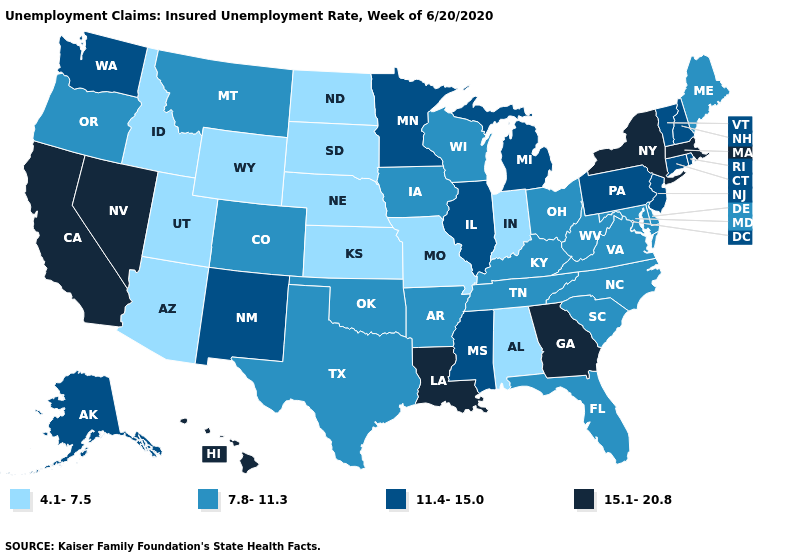What is the value of Louisiana?
Concise answer only. 15.1-20.8. What is the value of Colorado?
Quick response, please. 7.8-11.3. What is the highest value in the Northeast ?
Quick response, please. 15.1-20.8. What is the lowest value in states that border New York?
Short answer required. 11.4-15.0. Does Oklahoma have the same value as Texas?
Give a very brief answer. Yes. What is the value of Iowa?
Short answer required. 7.8-11.3. Does the first symbol in the legend represent the smallest category?
Give a very brief answer. Yes. What is the highest value in the USA?
Write a very short answer. 15.1-20.8. What is the value of South Dakota?
Be succinct. 4.1-7.5. What is the value of Delaware?
Keep it brief. 7.8-11.3. What is the value of Georgia?
Be succinct. 15.1-20.8. What is the value of Illinois?
Short answer required. 11.4-15.0. What is the lowest value in the West?
Concise answer only. 4.1-7.5. What is the highest value in the USA?
Concise answer only. 15.1-20.8. Does Connecticut have the lowest value in the Northeast?
Answer briefly. No. 